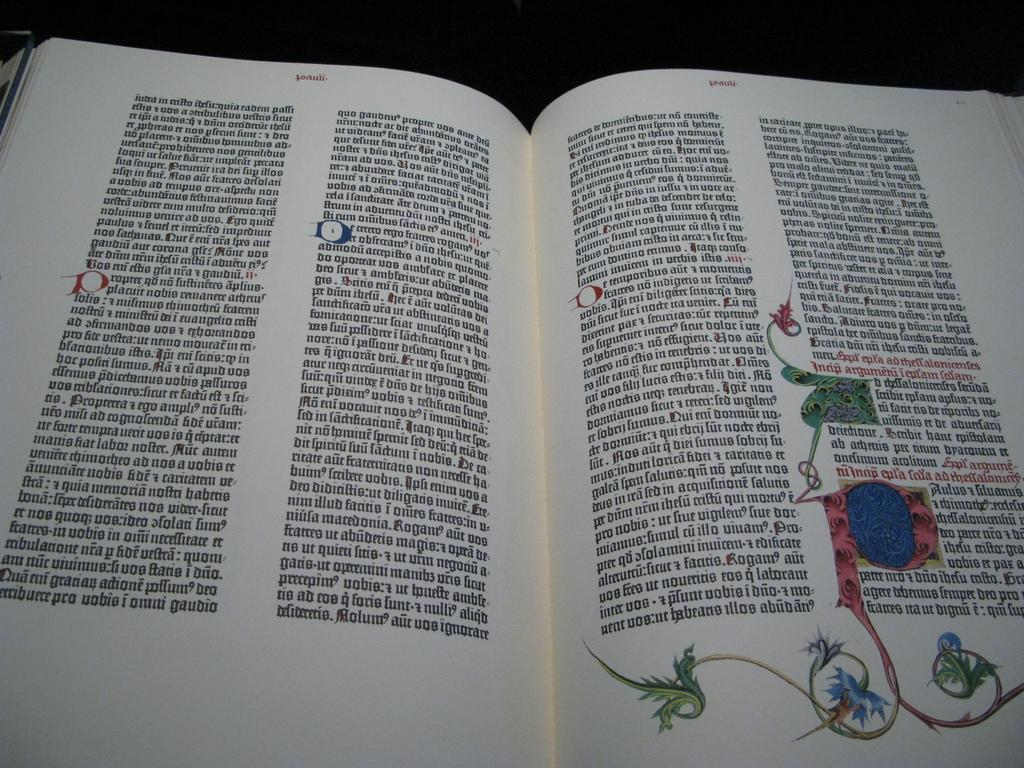What is the main object in the image? There is a book in the image. What is the state of the book? The book is opened. What can be seen on the right side of the book? There is a painting on the right side of the book. What color is the top part of the image? The top of the image appears to be black in color. What degree of yarn is required to complete the arithmetic problem in the image? There is no yarn or arithmetic problem present in the image, so this question cannot be answered. 